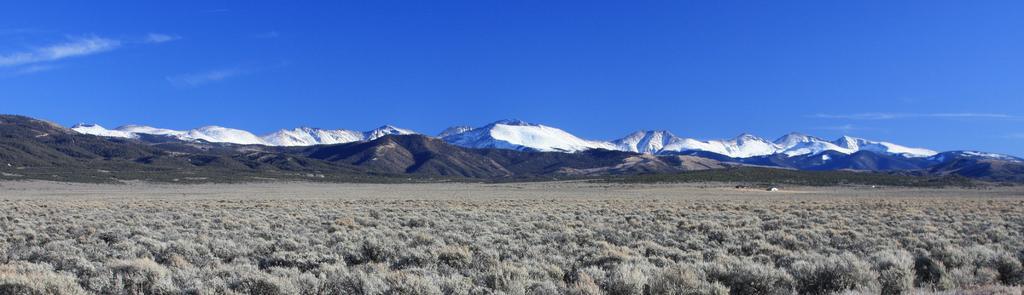Describe this image in one or two sentences. In this image there is dried grass and mountains which partially are partially covered with snow. 